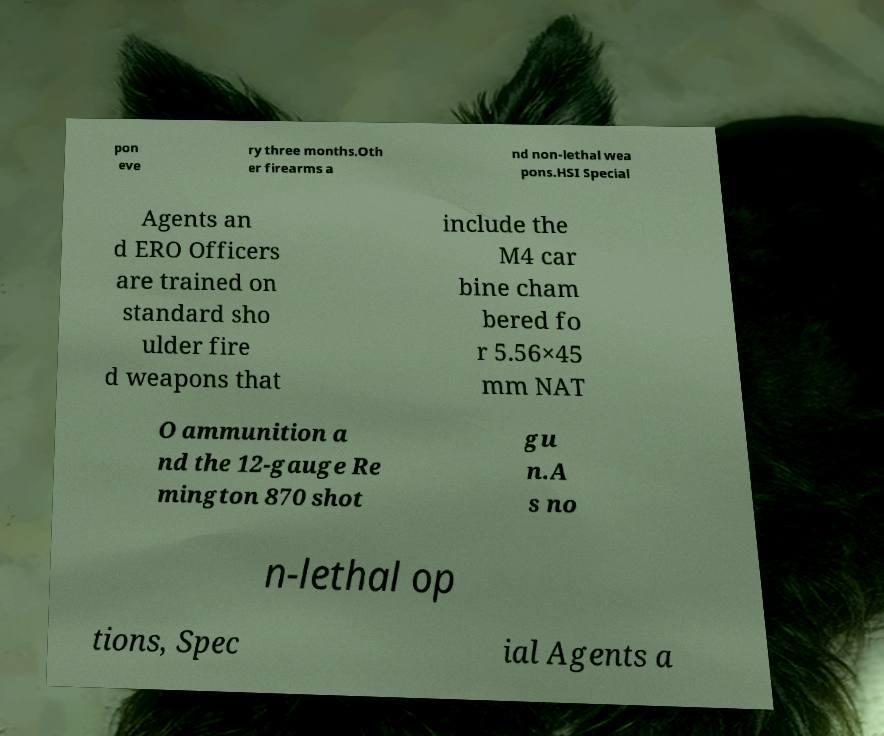Could you extract and type out the text from this image? pon eve ry three months.Oth er firearms a nd non-lethal wea pons.HSI Special Agents an d ERO Officers are trained on standard sho ulder fire d weapons that include the M4 car bine cham bered fo r 5.56×45 mm NAT O ammunition a nd the 12-gauge Re mington 870 shot gu n.A s no n-lethal op tions, Spec ial Agents a 